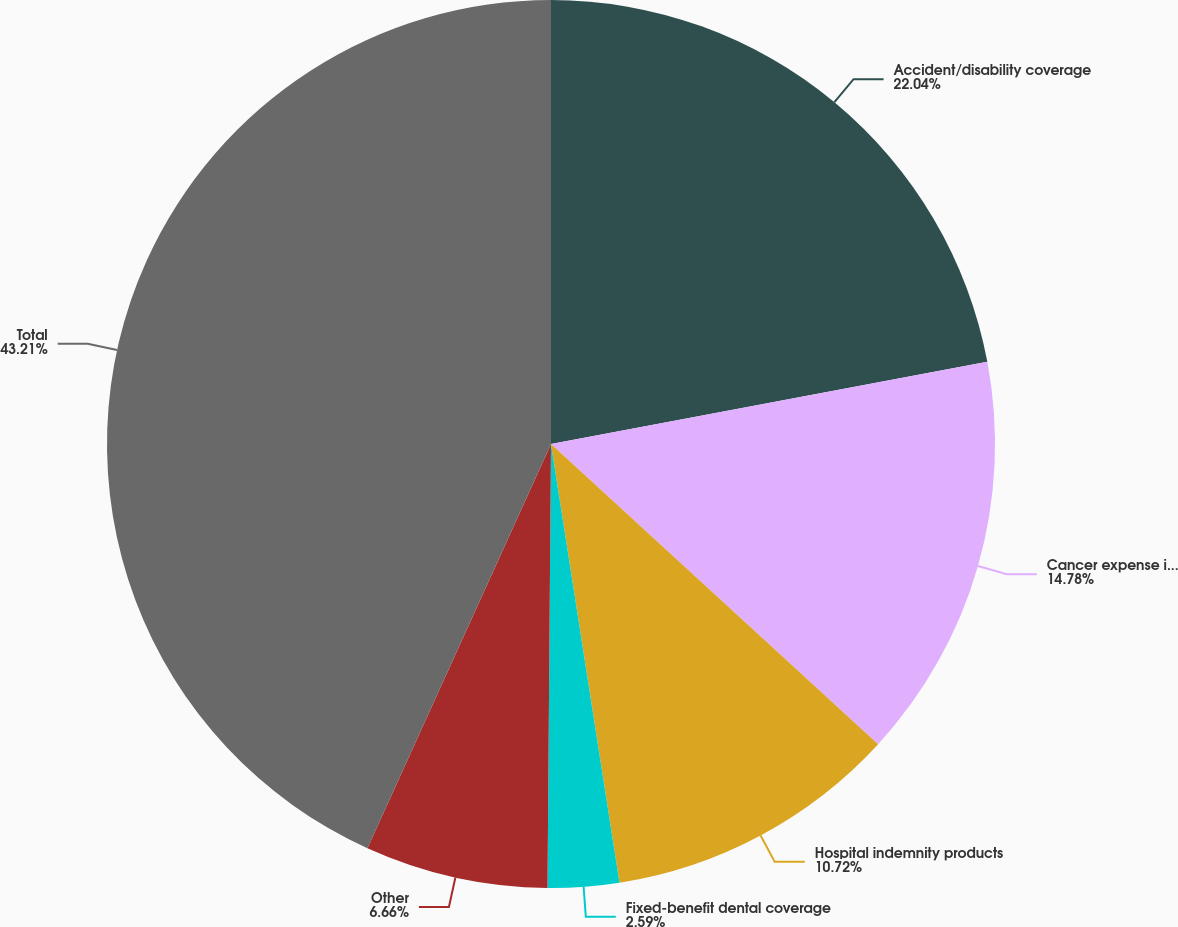Convert chart. <chart><loc_0><loc_0><loc_500><loc_500><pie_chart><fcel>Accident/disability coverage<fcel>Cancer expense insurance<fcel>Hospital indemnity products<fcel>Fixed-benefit dental coverage<fcel>Other<fcel>Total<nl><fcel>22.04%<fcel>14.78%<fcel>10.72%<fcel>2.59%<fcel>6.66%<fcel>43.22%<nl></chart> 